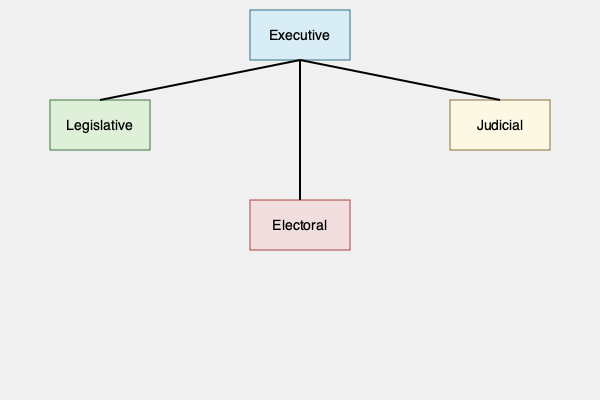Based on the organizational chart of Panama's government, which branch is uniquely positioned as a fourth power, separate from the traditional three branches, and what specific function does it serve in Panama's democratic system? 1. The organizational chart shows four main branches of Panama's government:
   - Executive (top)
   - Legislative (left)
   - Judicial (right)
   - Electoral (bottom)

2. In traditional governmental structures, there are typically three branches: executive, legislative, and judicial. This is known as the separation of powers.

3. Panama's governmental structure includes a fourth branch, the Electoral branch, which is unusual and specific to Panama's political system.

4. The Electoral branch is positioned separately from the other three branches in the chart, indicating its independence and equal status.

5. In Panama, the Electoral branch, also known as the Electoral Tribunal, serves a crucial function in the country's democratic system:
   - It is responsible for organizing, directing, and supervising the electoral process.
   - It ensures the integrity and transparency of elections.
   - It manages voter registration and identification.
   - It has the power to interpret and apply electoral laws.

6. The presence of an independent Electoral branch reflects Panama's commitment to fair and transparent elections, which is particularly significant given the country's history of political instability and military rule.
Answer: Electoral branch; organizes and oversees elections 